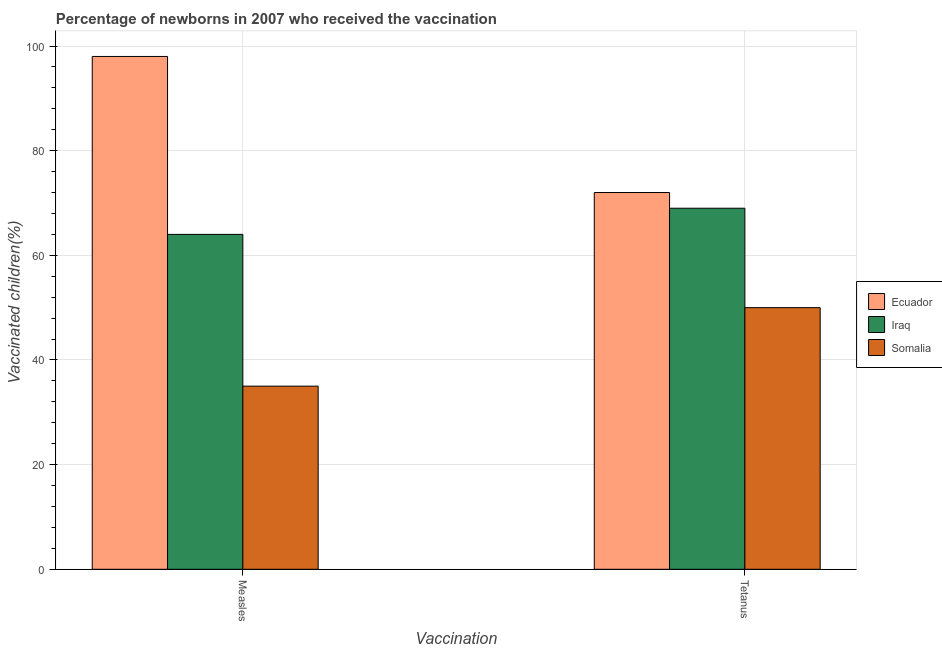Are the number of bars per tick equal to the number of legend labels?
Your response must be concise. Yes. What is the label of the 2nd group of bars from the left?
Ensure brevity in your answer.  Tetanus. What is the percentage of newborns who received vaccination for measles in Somalia?
Your response must be concise. 35. Across all countries, what is the maximum percentage of newborns who received vaccination for measles?
Your response must be concise. 98. Across all countries, what is the minimum percentage of newborns who received vaccination for tetanus?
Give a very brief answer. 50. In which country was the percentage of newborns who received vaccination for measles maximum?
Your response must be concise. Ecuador. In which country was the percentage of newborns who received vaccination for tetanus minimum?
Your answer should be very brief. Somalia. What is the total percentage of newborns who received vaccination for measles in the graph?
Offer a very short reply. 197. What is the difference between the percentage of newborns who received vaccination for tetanus in Ecuador and that in Somalia?
Provide a short and direct response. 22. What is the difference between the percentage of newborns who received vaccination for measles in Ecuador and the percentage of newborns who received vaccination for tetanus in Iraq?
Provide a succinct answer. 29. What is the average percentage of newborns who received vaccination for measles per country?
Your answer should be very brief. 65.67. What is the difference between the percentage of newborns who received vaccination for measles and percentage of newborns who received vaccination for tetanus in Ecuador?
Provide a short and direct response. 26. What is the ratio of the percentage of newborns who received vaccination for tetanus in Somalia to that in Ecuador?
Your answer should be very brief. 0.69. What does the 2nd bar from the left in Measles represents?
Offer a terse response. Iraq. What does the 1st bar from the right in Measles represents?
Offer a terse response. Somalia. How many bars are there?
Make the answer very short. 6. Are all the bars in the graph horizontal?
Offer a terse response. No. Does the graph contain any zero values?
Offer a terse response. No. How many legend labels are there?
Offer a very short reply. 3. What is the title of the graph?
Make the answer very short. Percentage of newborns in 2007 who received the vaccination. What is the label or title of the X-axis?
Your answer should be compact. Vaccination. What is the label or title of the Y-axis?
Your response must be concise. Vaccinated children(%)
. What is the Vaccinated children(%)
 of Ecuador in Measles?
Give a very brief answer. 98. What is the Vaccinated children(%)
 in Somalia in Measles?
Offer a very short reply. 35. What is the Vaccinated children(%)
 of Ecuador in Tetanus?
Offer a terse response. 72. What is the Vaccinated children(%)
 of Iraq in Tetanus?
Your response must be concise. 69. Across all Vaccination, what is the maximum Vaccinated children(%)
 in Ecuador?
Give a very brief answer. 98. Across all Vaccination, what is the minimum Vaccinated children(%)
 of Iraq?
Offer a terse response. 64. What is the total Vaccinated children(%)
 of Ecuador in the graph?
Your answer should be very brief. 170. What is the total Vaccinated children(%)
 in Iraq in the graph?
Provide a succinct answer. 133. What is the difference between the Vaccinated children(%)
 in Ecuador in Measles and the Vaccinated children(%)
 in Iraq in Tetanus?
Your answer should be very brief. 29. What is the difference between the Vaccinated children(%)
 in Ecuador in Measles and the Vaccinated children(%)
 in Somalia in Tetanus?
Offer a terse response. 48. What is the average Vaccinated children(%)
 in Iraq per Vaccination?
Provide a short and direct response. 66.5. What is the average Vaccinated children(%)
 of Somalia per Vaccination?
Provide a succinct answer. 42.5. What is the difference between the Vaccinated children(%)
 of Ecuador and Vaccinated children(%)
 of Somalia in Measles?
Offer a very short reply. 63. What is the difference between the Vaccinated children(%)
 in Ecuador and Vaccinated children(%)
 in Somalia in Tetanus?
Make the answer very short. 22. What is the difference between the Vaccinated children(%)
 of Iraq and Vaccinated children(%)
 of Somalia in Tetanus?
Your answer should be very brief. 19. What is the ratio of the Vaccinated children(%)
 of Ecuador in Measles to that in Tetanus?
Your answer should be compact. 1.36. What is the ratio of the Vaccinated children(%)
 of Iraq in Measles to that in Tetanus?
Make the answer very short. 0.93. What is the ratio of the Vaccinated children(%)
 of Somalia in Measles to that in Tetanus?
Your answer should be compact. 0.7. What is the difference between the highest and the lowest Vaccinated children(%)
 of Ecuador?
Your answer should be very brief. 26. What is the difference between the highest and the lowest Vaccinated children(%)
 of Iraq?
Provide a short and direct response. 5. What is the difference between the highest and the lowest Vaccinated children(%)
 in Somalia?
Offer a terse response. 15. 